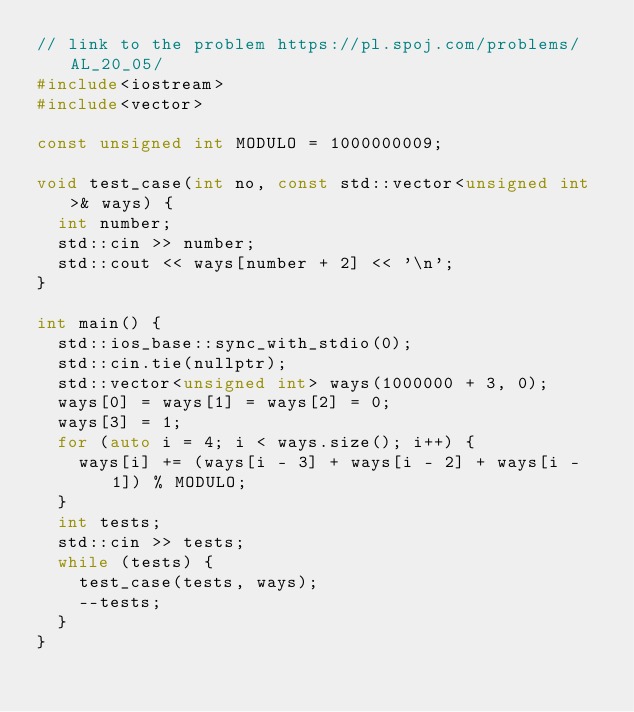<code> <loc_0><loc_0><loc_500><loc_500><_C++_>// link to the problem https://pl.spoj.com/problems/AL_20_05/
#include<iostream>
#include<vector>

const unsigned int MODULO = 1000000009;

void test_case(int no, const std::vector<unsigned int>& ways) {
	int number;
	std::cin >> number;
	std::cout << ways[number + 2] << '\n';
}

int main() {
	std::ios_base::sync_with_stdio(0);
	std::cin.tie(nullptr);
	std::vector<unsigned int> ways(1000000 + 3, 0);
	ways[0] = ways[1] = ways[2] = 0;
	ways[3] = 1;
	for (auto i = 4; i < ways.size(); i++) {
		ways[i] += (ways[i - 3] + ways[i - 2] + ways[i - 1]) % MODULO;
	}
	int tests;
	std::cin >> tests;
	while (tests) {
		test_case(tests, ways);
		--tests;
	}
}</code> 